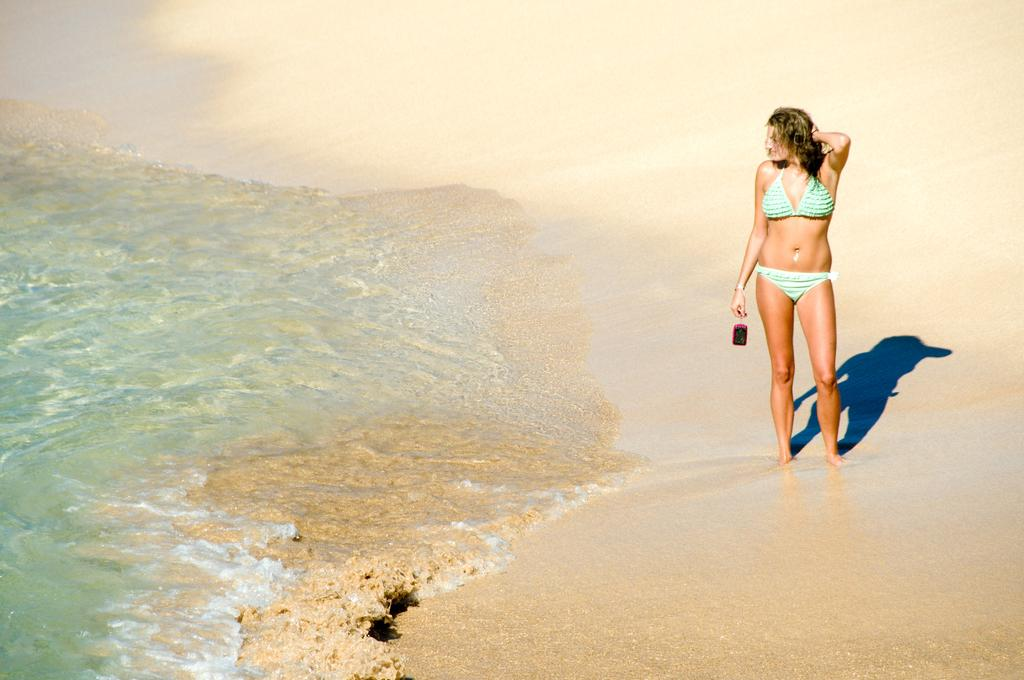What is the main subject of the image? The main subject of the image is a woman. What is the woman holding in the image? The woman is holding a bottle. What can be seen in the background of the image? There is water visible in the image. What type of camp can be seen in the background of the image? There is no camp present in the image; it features a woman holding a bottle with water visible in the background. How many pages are visible in the image? There are no pages present in the image. 